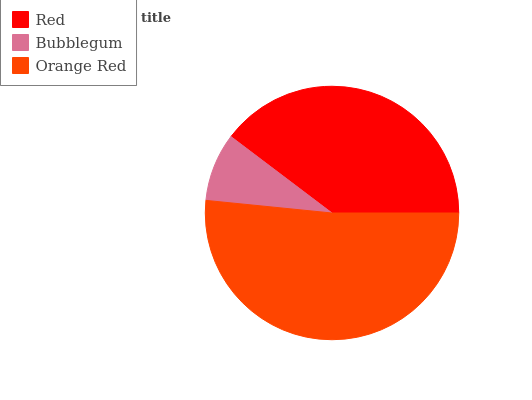Is Bubblegum the minimum?
Answer yes or no. Yes. Is Orange Red the maximum?
Answer yes or no. Yes. Is Orange Red the minimum?
Answer yes or no. No. Is Bubblegum the maximum?
Answer yes or no. No. Is Orange Red greater than Bubblegum?
Answer yes or no. Yes. Is Bubblegum less than Orange Red?
Answer yes or no. Yes. Is Bubblegum greater than Orange Red?
Answer yes or no. No. Is Orange Red less than Bubblegum?
Answer yes or no. No. Is Red the high median?
Answer yes or no. Yes. Is Red the low median?
Answer yes or no. Yes. Is Bubblegum the high median?
Answer yes or no. No. Is Orange Red the low median?
Answer yes or no. No. 